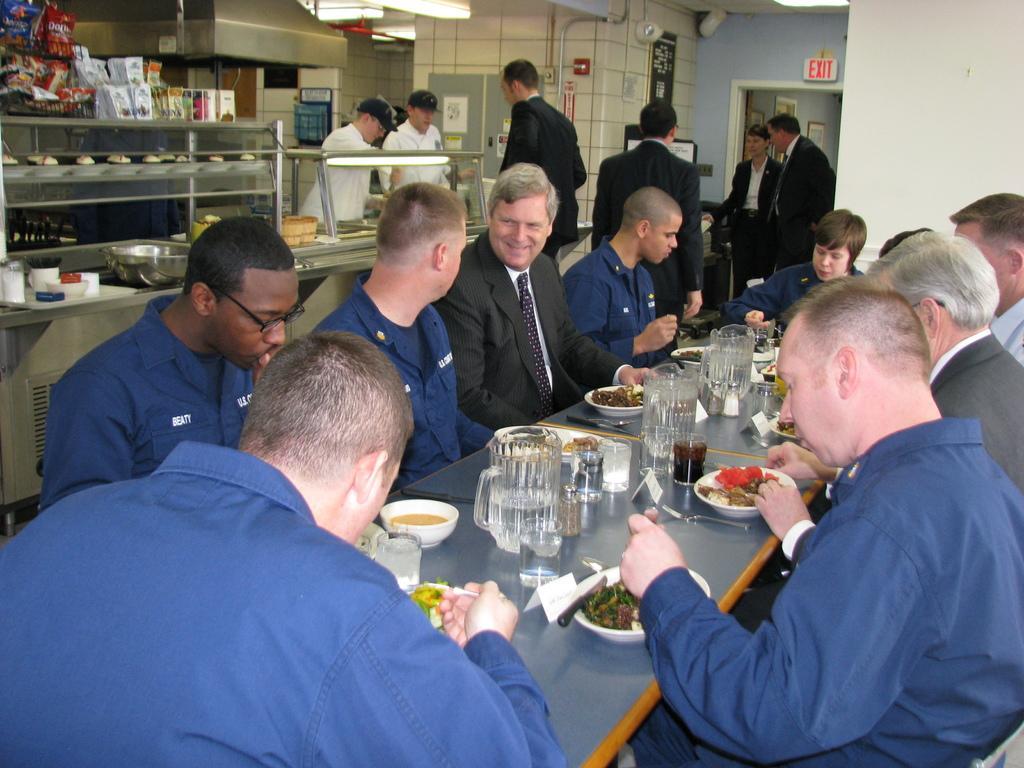How would you summarize this image in a sentence or two? This picture describes about group of people, few are seated on the chairs, and few are standing, in front of them we can see few glasses, plates, bowls and other things on the table, in the background we can see few packets and lights. 